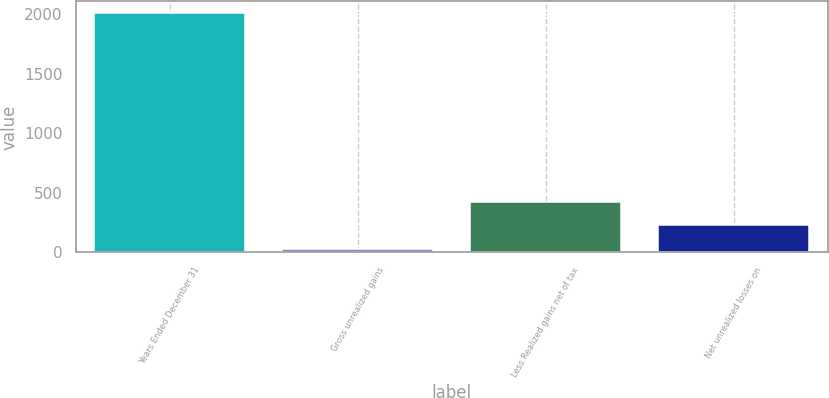Convert chart. <chart><loc_0><loc_0><loc_500><loc_500><bar_chart><fcel>Years Ended December 31<fcel>Gross unrealized gains<fcel>Less Realized gains net of tax<fcel>Net unrealized losses on<nl><fcel>2006<fcel>31<fcel>426<fcel>228.5<nl></chart> 